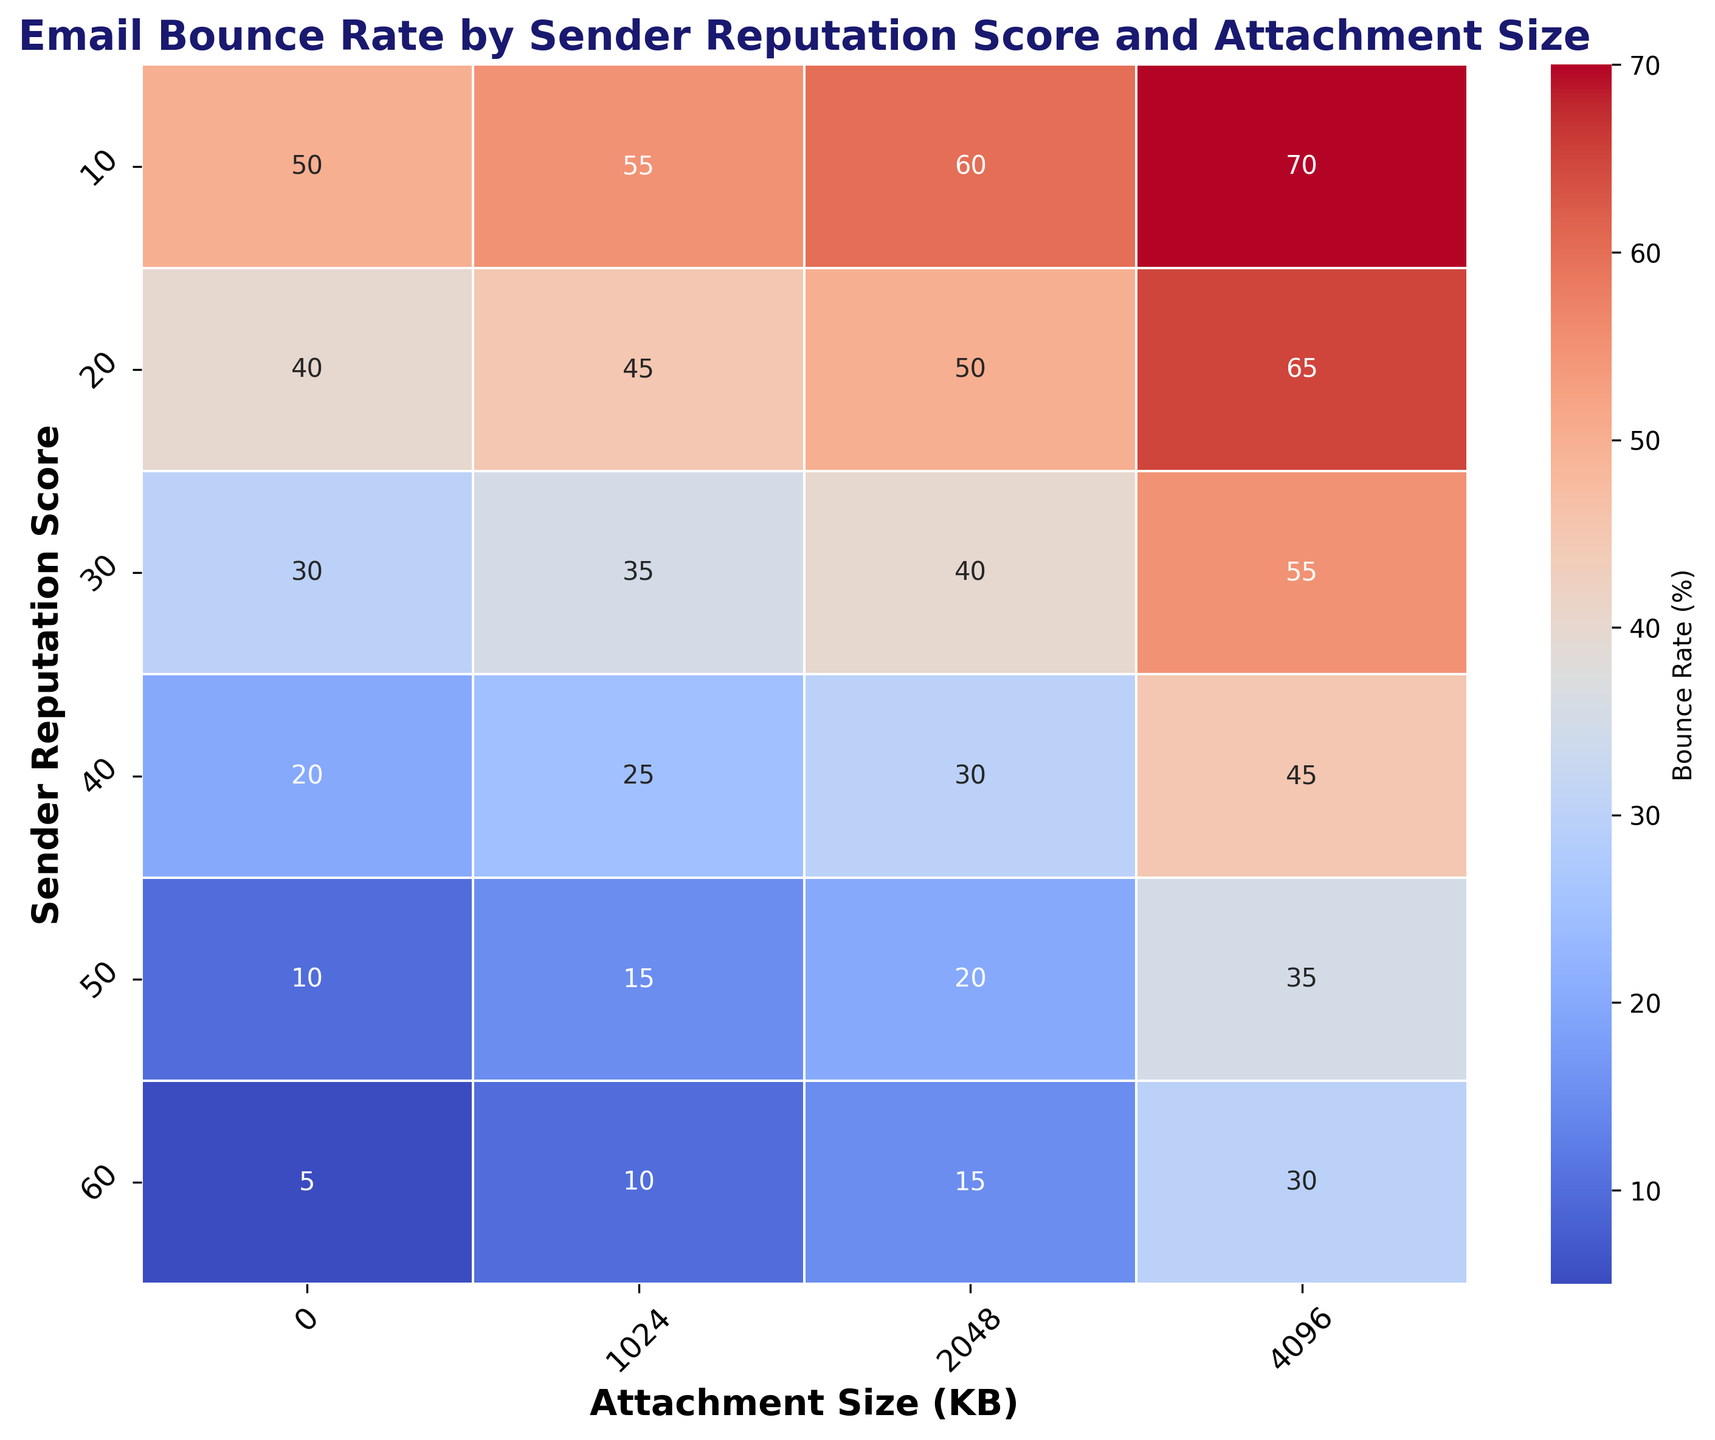Which combination of sender reputation score and attachment size has the highest bounce rate? In the heatmap, the highest bounce rate value is indicated by the most intense color. By looking at the values, the combination of sender reputation score 10 and attachment size 4096 KB has the highest bounce rate of 70%.
Answer: Sender reputation score 10 and attachment size 4096 KB Which sender reputation score has the lowest bounce rate for an attachment size of 2048 KB? Looking at the column for attachment size 2048 KB, the lowest bounce rate corresponds to the sender reputation score of 60, with a bounce rate of 15%.
Answer: Sender reputation score 60 How does the bounce rate change as the attachment size increases for a sender reputation score of 30? Observing the row for sender reputation score 30, the bounce rate increases as the attachment size increases: (0 KB -> 30%, 1024 KB -> 35%, 2048 KB -> 40%, 4096 KB -> 55%).
Answer: Increases Which attachment size consistently has the lowest bounce rates across different sender reputation scores? For each column, compare the bounce rates across different sender reputation scores. The 0 KB attachment size consistently has the lowest bounce rates (5%, 10%, 20%, 30%, 40%, 50%).
Answer: 0 KB Compare the bounce rates for sender reputation score 20 and attachment sizes 1024 KB and 4096 KB. For sender reputation score 20, the bounce rate for an attachment size of 1024 KB is 45%, and for 4096 KB it is 65%. Comparing these, the bounce rate is higher for 4096 KB.
Answer: 65% (4096 KB) is higher than 45% (1024 KB) For which attachment size does the bounce rate decrease the most as sender reputation score improves from 10 to 60? Analyze each column for different attachment sizes to find the difference in bounce rates from sender reputation score 10 to 60. The decrease is: 0 KB (50% to 5%, a drop of 45%), 1024 KB (55% to 10%, a drop of 45%), 2048 KB (60% to 15%, a drop of 45%), 4096 KB (70% to 30%, a drop of 40%). The attachment size where the bounce rate decreases the most is both 0 KB, 1024 KB, and 2048 KB.
Answer: 0 KB, 1024 KB, and 2048 KB Compare the trends for bounce rates as the sender reputation score increases for attachment sizes 0 KB and 4096 KB. For 0 KB, as the sender reputation score increases, the bounce rate steadily decreases from 50% to 5%. For 4096 KB, the bounce rate still decreases but is less steep, from 70% to 30%.
Answer: Both decrease, but 0 KB trend is steeper What is the difference in bounce rate between the highest and lowest sender reputation scores for an attachment size of 2048 KB? For the 2048 KB attachment size, the highest bounce rate is 60% (sender reputation score 10), and the lowest is 15% (sender reputation score 60). The difference is 60% - 15%.
Answer: 45% 